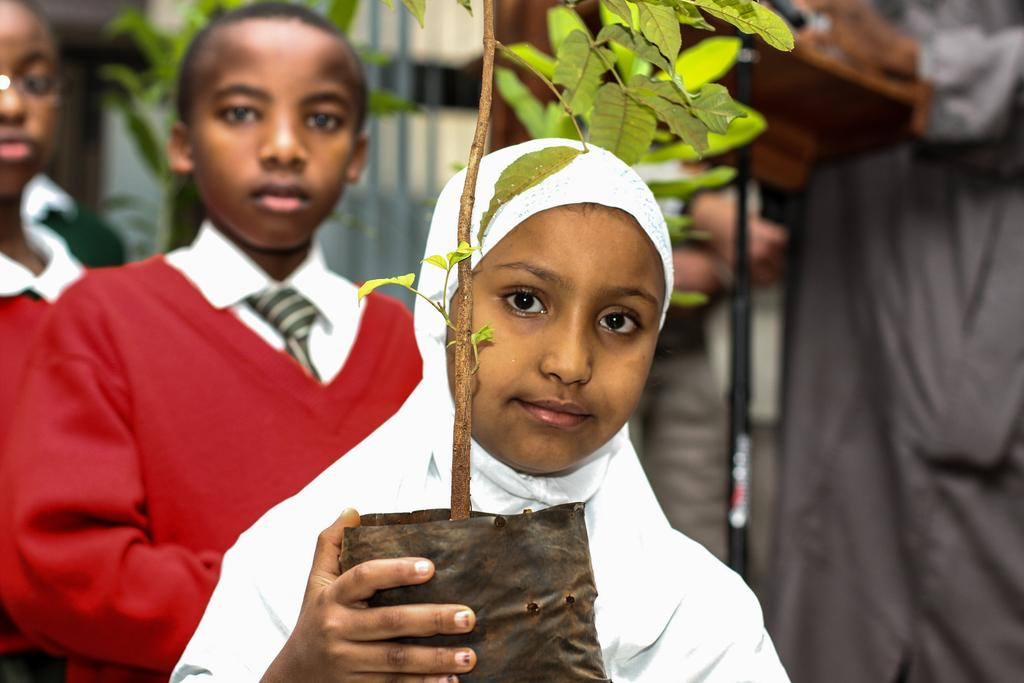What is the kid in the foreground of the image holding? The kid is holding a plant in the image. How many other kids are visible in the image? There are two other kids behind the first kid in the image. Can you describe the person visible in the image? Unfortunately, the facts provided do not give any details about the person in the image. What can be seen in the background of the image? There are blurred objects in the background of the image. Can you tell me how many kittens are playing in the quicksand in the image? There are no kittens or quicksand present in the image. 